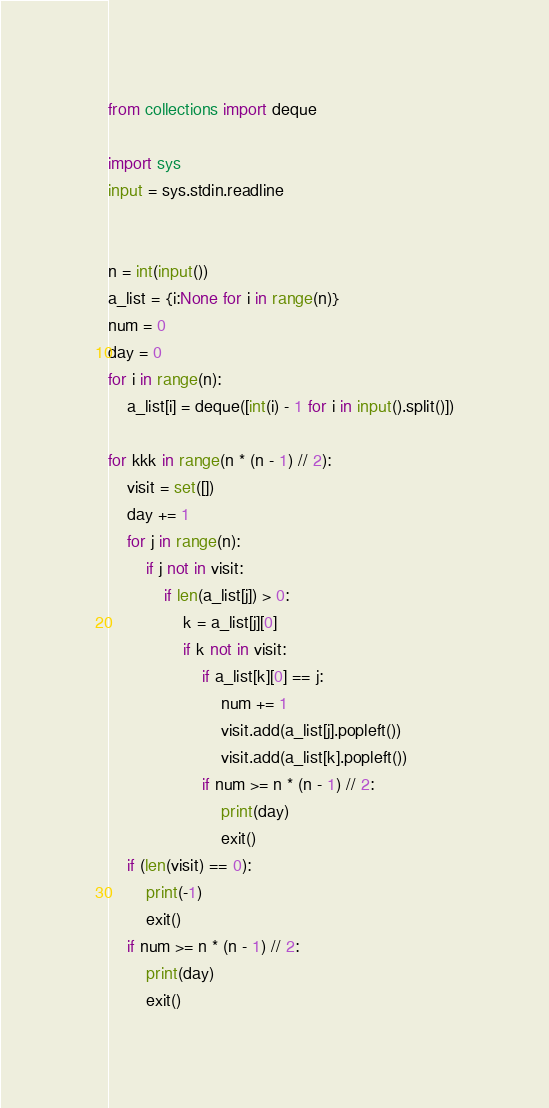Convert code to text. <code><loc_0><loc_0><loc_500><loc_500><_Python_>from collections import deque

import sys
input = sys.stdin.readline


n = int(input())
a_list = {i:None for i in range(n)}
num = 0
day = 0
for i in range(n):
    a_list[i] = deque([int(i) - 1 for i in input().split()])

for kkk in range(n * (n - 1) // 2):
    visit = set([])
    day += 1
    for j in range(n):
        if j not in visit:
            if len(a_list[j]) > 0:
                k = a_list[j][0]
                if k not in visit:
                    if a_list[k][0] == j:
                        num += 1
                        visit.add(a_list[j].popleft())
                        visit.add(a_list[k].popleft())
                    if num >= n * (n - 1) // 2:
                        print(day)
                        exit()
    if (len(visit) == 0):
        print(-1)
        exit()
    if num >= n * (n - 1) // 2:
        print(day)
        exit()</code> 